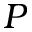<formula> <loc_0><loc_0><loc_500><loc_500>P</formula> 